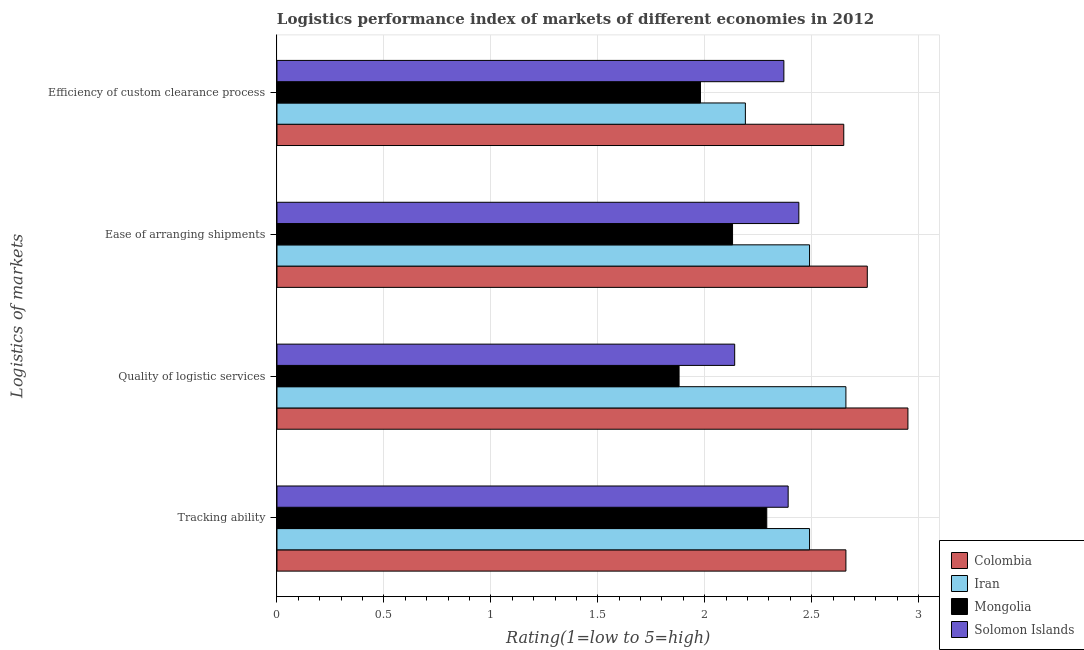How many groups of bars are there?
Your response must be concise. 4. Are the number of bars per tick equal to the number of legend labels?
Your answer should be very brief. Yes. What is the label of the 1st group of bars from the top?
Provide a succinct answer. Efficiency of custom clearance process. What is the lpi rating of ease of arranging shipments in Iran?
Provide a short and direct response. 2.49. Across all countries, what is the maximum lpi rating of quality of logistic services?
Provide a short and direct response. 2.95. Across all countries, what is the minimum lpi rating of ease of arranging shipments?
Your answer should be compact. 2.13. In which country was the lpi rating of quality of logistic services minimum?
Offer a very short reply. Mongolia. What is the total lpi rating of efficiency of custom clearance process in the graph?
Give a very brief answer. 9.19. What is the difference between the lpi rating of ease of arranging shipments in Iran and that in Solomon Islands?
Provide a short and direct response. 0.05. What is the difference between the lpi rating of efficiency of custom clearance process in Iran and the lpi rating of tracking ability in Mongolia?
Keep it short and to the point. -0.1. What is the average lpi rating of quality of logistic services per country?
Your answer should be very brief. 2.41. What is the difference between the lpi rating of ease of arranging shipments and lpi rating of tracking ability in Colombia?
Offer a terse response. 0.1. In how many countries, is the lpi rating of ease of arranging shipments greater than 0.7 ?
Give a very brief answer. 4. What is the ratio of the lpi rating of tracking ability in Iran to that in Colombia?
Your response must be concise. 0.94. Is the lpi rating of tracking ability in Mongolia less than that in Colombia?
Provide a short and direct response. Yes. Is the difference between the lpi rating of efficiency of custom clearance process in Colombia and Iran greater than the difference between the lpi rating of ease of arranging shipments in Colombia and Iran?
Give a very brief answer. Yes. What is the difference between the highest and the second highest lpi rating of quality of logistic services?
Offer a terse response. 0.29. What is the difference between the highest and the lowest lpi rating of tracking ability?
Your response must be concise. 0.37. In how many countries, is the lpi rating of efficiency of custom clearance process greater than the average lpi rating of efficiency of custom clearance process taken over all countries?
Offer a very short reply. 2. Is the sum of the lpi rating of quality of logistic services in Solomon Islands and Mongolia greater than the maximum lpi rating of efficiency of custom clearance process across all countries?
Offer a very short reply. Yes. What does the 2nd bar from the top in Efficiency of custom clearance process represents?
Your answer should be very brief. Mongolia. Are all the bars in the graph horizontal?
Your response must be concise. Yes. How many countries are there in the graph?
Keep it short and to the point. 4. Are the values on the major ticks of X-axis written in scientific E-notation?
Offer a very short reply. No. How many legend labels are there?
Provide a short and direct response. 4. How are the legend labels stacked?
Your response must be concise. Vertical. What is the title of the graph?
Provide a short and direct response. Logistics performance index of markets of different economies in 2012. Does "Poland" appear as one of the legend labels in the graph?
Keep it short and to the point. No. What is the label or title of the X-axis?
Offer a very short reply. Rating(1=low to 5=high). What is the label or title of the Y-axis?
Provide a short and direct response. Logistics of markets. What is the Rating(1=low to 5=high) of Colombia in Tracking ability?
Your response must be concise. 2.66. What is the Rating(1=low to 5=high) of Iran in Tracking ability?
Make the answer very short. 2.49. What is the Rating(1=low to 5=high) in Mongolia in Tracking ability?
Offer a very short reply. 2.29. What is the Rating(1=low to 5=high) in Solomon Islands in Tracking ability?
Your answer should be compact. 2.39. What is the Rating(1=low to 5=high) of Colombia in Quality of logistic services?
Make the answer very short. 2.95. What is the Rating(1=low to 5=high) in Iran in Quality of logistic services?
Keep it short and to the point. 2.66. What is the Rating(1=low to 5=high) of Mongolia in Quality of logistic services?
Ensure brevity in your answer.  1.88. What is the Rating(1=low to 5=high) of Solomon Islands in Quality of logistic services?
Offer a terse response. 2.14. What is the Rating(1=low to 5=high) in Colombia in Ease of arranging shipments?
Make the answer very short. 2.76. What is the Rating(1=low to 5=high) in Iran in Ease of arranging shipments?
Your answer should be compact. 2.49. What is the Rating(1=low to 5=high) in Mongolia in Ease of arranging shipments?
Provide a short and direct response. 2.13. What is the Rating(1=low to 5=high) in Solomon Islands in Ease of arranging shipments?
Your answer should be compact. 2.44. What is the Rating(1=low to 5=high) in Colombia in Efficiency of custom clearance process?
Your answer should be compact. 2.65. What is the Rating(1=low to 5=high) in Iran in Efficiency of custom clearance process?
Give a very brief answer. 2.19. What is the Rating(1=low to 5=high) of Mongolia in Efficiency of custom clearance process?
Offer a terse response. 1.98. What is the Rating(1=low to 5=high) of Solomon Islands in Efficiency of custom clearance process?
Your answer should be very brief. 2.37. Across all Logistics of markets, what is the maximum Rating(1=low to 5=high) of Colombia?
Ensure brevity in your answer.  2.95. Across all Logistics of markets, what is the maximum Rating(1=low to 5=high) in Iran?
Give a very brief answer. 2.66. Across all Logistics of markets, what is the maximum Rating(1=low to 5=high) of Mongolia?
Your response must be concise. 2.29. Across all Logistics of markets, what is the maximum Rating(1=low to 5=high) of Solomon Islands?
Offer a very short reply. 2.44. Across all Logistics of markets, what is the minimum Rating(1=low to 5=high) in Colombia?
Keep it short and to the point. 2.65. Across all Logistics of markets, what is the minimum Rating(1=low to 5=high) in Iran?
Your answer should be compact. 2.19. Across all Logistics of markets, what is the minimum Rating(1=low to 5=high) of Mongolia?
Give a very brief answer. 1.88. Across all Logistics of markets, what is the minimum Rating(1=low to 5=high) of Solomon Islands?
Give a very brief answer. 2.14. What is the total Rating(1=low to 5=high) of Colombia in the graph?
Make the answer very short. 11.02. What is the total Rating(1=low to 5=high) of Iran in the graph?
Your response must be concise. 9.83. What is the total Rating(1=low to 5=high) of Mongolia in the graph?
Make the answer very short. 8.28. What is the total Rating(1=low to 5=high) of Solomon Islands in the graph?
Provide a succinct answer. 9.34. What is the difference between the Rating(1=low to 5=high) of Colombia in Tracking ability and that in Quality of logistic services?
Offer a very short reply. -0.29. What is the difference between the Rating(1=low to 5=high) of Iran in Tracking ability and that in Quality of logistic services?
Offer a terse response. -0.17. What is the difference between the Rating(1=low to 5=high) of Mongolia in Tracking ability and that in Quality of logistic services?
Your answer should be compact. 0.41. What is the difference between the Rating(1=low to 5=high) in Iran in Tracking ability and that in Ease of arranging shipments?
Provide a succinct answer. 0. What is the difference between the Rating(1=low to 5=high) in Mongolia in Tracking ability and that in Ease of arranging shipments?
Your answer should be compact. 0.16. What is the difference between the Rating(1=low to 5=high) in Colombia in Tracking ability and that in Efficiency of custom clearance process?
Your answer should be very brief. 0.01. What is the difference between the Rating(1=low to 5=high) of Iran in Tracking ability and that in Efficiency of custom clearance process?
Provide a short and direct response. 0.3. What is the difference between the Rating(1=low to 5=high) of Mongolia in Tracking ability and that in Efficiency of custom clearance process?
Your answer should be compact. 0.31. What is the difference between the Rating(1=low to 5=high) of Colombia in Quality of logistic services and that in Ease of arranging shipments?
Provide a short and direct response. 0.19. What is the difference between the Rating(1=low to 5=high) in Iran in Quality of logistic services and that in Ease of arranging shipments?
Offer a terse response. 0.17. What is the difference between the Rating(1=low to 5=high) in Iran in Quality of logistic services and that in Efficiency of custom clearance process?
Provide a succinct answer. 0.47. What is the difference between the Rating(1=low to 5=high) in Mongolia in Quality of logistic services and that in Efficiency of custom clearance process?
Provide a succinct answer. -0.1. What is the difference between the Rating(1=low to 5=high) in Solomon Islands in Quality of logistic services and that in Efficiency of custom clearance process?
Your response must be concise. -0.23. What is the difference between the Rating(1=low to 5=high) in Colombia in Ease of arranging shipments and that in Efficiency of custom clearance process?
Provide a short and direct response. 0.11. What is the difference between the Rating(1=low to 5=high) of Iran in Ease of arranging shipments and that in Efficiency of custom clearance process?
Your response must be concise. 0.3. What is the difference between the Rating(1=low to 5=high) in Mongolia in Ease of arranging shipments and that in Efficiency of custom clearance process?
Provide a succinct answer. 0.15. What is the difference between the Rating(1=low to 5=high) of Solomon Islands in Ease of arranging shipments and that in Efficiency of custom clearance process?
Offer a very short reply. 0.07. What is the difference between the Rating(1=low to 5=high) of Colombia in Tracking ability and the Rating(1=low to 5=high) of Mongolia in Quality of logistic services?
Offer a very short reply. 0.78. What is the difference between the Rating(1=low to 5=high) of Colombia in Tracking ability and the Rating(1=low to 5=high) of Solomon Islands in Quality of logistic services?
Provide a succinct answer. 0.52. What is the difference between the Rating(1=low to 5=high) in Iran in Tracking ability and the Rating(1=low to 5=high) in Mongolia in Quality of logistic services?
Ensure brevity in your answer.  0.61. What is the difference between the Rating(1=low to 5=high) of Iran in Tracking ability and the Rating(1=low to 5=high) of Solomon Islands in Quality of logistic services?
Ensure brevity in your answer.  0.35. What is the difference between the Rating(1=low to 5=high) in Mongolia in Tracking ability and the Rating(1=low to 5=high) in Solomon Islands in Quality of logistic services?
Make the answer very short. 0.15. What is the difference between the Rating(1=low to 5=high) in Colombia in Tracking ability and the Rating(1=low to 5=high) in Iran in Ease of arranging shipments?
Make the answer very short. 0.17. What is the difference between the Rating(1=low to 5=high) in Colombia in Tracking ability and the Rating(1=low to 5=high) in Mongolia in Ease of arranging shipments?
Your response must be concise. 0.53. What is the difference between the Rating(1=low to 5=high) in Colombia in Tracking ability and the Rating(1=low to 5=high) in Solomon Islands in Ease of arranging shipments?
Your answer should be compact. 0.22. What is the difference between the Rating(1=low to 5=high) of Iran in Tracking ability and the Rating(1=low to 5=high) of Mongolia in Ease of arranging shipments?
Offer a terse response. 0.36. What is the difference between the Rating(1=low to 5=high) of Iran in Tracking ability and the Rating(1=low to 5=high) of Solomon Islands in Ease of arranging shipments?
Offer a terse response. 0.05. What is the difference between the Rating(1=low to 5=high) in Colombia in Tracking ability and the Rating(1=low to 5=high) in Iran in Efficiency of custom clearance process?
Keep it short and to the point. 0.47. What is the difference between the Rating(1=low to 5=high) of Colombia in Tracking ability and the Rating(1=low to 5=high) of Mongolia in Efficiency of custom clearance process?
Offer a very short reply. 0.68. What is the difference between the Rating(1=low to 5=high) in Colombia in Tracking ability and the Rating(1=low to 5=high) in Solomon Islands in Efficiency of custom clearance process?
Your response must be concise. 0.29. What is the difference between the Rating(1=low to 5=high) in Iran in Tracking ability and the Rating(1=low to 5=high) in Mongolia in Efficiency of custom clearance process?
Ensure brevity in your answer.  0.51. What is the difference between the Rating(1=low to 5=high) of Iran in Tracking ability and the Rating(1=low to 5=high) of Solomon Islands in Efficiency of custom clearance process?
Your response must be concise. 0.12. What is the difference between the Rating(1=low to 5=high) in Mongolia in Tracking ability and the Rating(1=low to 5=high) in Solomon Islands in Efficiency of custom clearance process?
Keep it short and to the point. -0.08. What is the difference between the Rating(1=low to 5=high) in Colombia in Quality of logistic services and the Rating(1=low to 5=high) in Iran in Ease of arranging shipments?
Offer a terse response. 0.46. What is the difference between the Rating(1=low to 5=high) of Colombia in Quality of logistic services and the Rating(1=low to 5=high) of Mongolia in Ease of arranging shipments?
Your answer should be compact. 0.82. What is the difference between the Rating(1=low to 5=high) of Colombia in Quality of logistic services and the Rating(1=low to 5=high) of Solomon Islands in Ease of arranging shipments?
Keep it short and to the point. 0.51. What is the difference between the Rating(1=low to 5=high) in Iran in Quality of logistic services and the Rating(1=low to 5=high) in Mongolia in Ease of arranging shipments?
Offer a terse response. 0.53. What is the difference between the Rating(1=low to 5=high) of Iran in Quality of logistic services and the Rating(1=low to 5=high) of Solomon Islands in Ease of arranging shipments?
Your answer should be compact. 0.22. What is the difference between the Rating(1=low to 5=high) in Mongolia in Quality of logistic services and the Rating(1=low to 5=high) in Solomon Islands in Ease of arranging shipments?
Provide a short and direct response. -0.56. What is the difference between the Rating(1=low to 5=high) of Colombia in Quality of logistic services and the Rating(1=low to 5=high) of Iran in Efficiency of custom clearance process?
Keep it short and to the point. 0.76. What is the difference between the Rating(1=low to 5=high) of Colombia in Quality of logistic services and the Rating(1=low to 5=high) of Solomon Islands in Efficiency of custom clearance process?
Your answer should be very brief. 0.58. What is the difference between the Rating(1=low to 5=high) of Iran in Quality of logistic services and the Rating(1=low to 5=high) of Mongolia in Efficiency of custom clearance process?
Your answer should be compact. 0.68. What is the difference between the Rating(1=low to 5=high) of Iran in Quality of logistic services and the Rating(1=low to 5=high) of Solomon Islands in Efficiency of custom clearance process?
Your answer should be compact. 0.29. What is the difference between the Rating(1=low to 5=high) of Mongolia in Quality of logistic services and the Rating(1=low to 5=high) of Solomon Islands in Efficiency of custom clearance process?
Make the answer very short. -0.49. What is the difference between the Rating(1=low to 5=high) of Colombia in Ease of arranging shipments and the Rating(1=low to 5=high) of Iran in Efficiency of custom clearance process?
Your response must be concise. 0.57. What is the difference between the Rating(1=low to 5=high) of Colombia in Ease of arranging shipments and the Rating(1=low to 5=high) of Mongolia in Efficiency of custom clearance process?
Make the answer very short. 0.78. What is the difference between the Rating(1=low to 5=high) in Colombia in Ease of arranging shipments and the Rating(1=low to 5=high) in Solomon Islands in Efficiency of custom clearance process?
Give a very brief answer. 0.39. What is the difference between the Rating(1=low to 5=high) in Iran in Ease of arranging shipments and the Rating(1=low to 5=high) in Mongolia in Efficiency of custom clearance process?
Keep it short and to the point. 0.51. What is the difference between the Rating(1=low to 5=high) in Iran in Ease of arranging shipments and the Rating(1=low to 5=high) in Solomon Islands in Efficiency of custom clearance process?
Keep it short and to the point. 0.12. What is the difference between the Rating(1=low to 5=high) in Mongolia in Ease of arranging shipments and the Rating(1=low to 5=high) in Solomon Islands in Efficiency of custom clearance process?
Provide a short and direct response. -0.24. What is the average Rating(1=low to 5=high) of Colombia per Logistics of markets?
Provide a succinct answer. 2.75. What is the average Rating(1=low to 5=high) in Iran per Logistics of markets?
Offer a very short reply. 2.46. What is the average Rating(1=low to 5=high) in Mongolia per Logistics of markets?
Keep it short and to the point. 2.07. What is the average Rating(1=low to 5=high) of Solomon Islands per Logistics of markets?
Ensure brevity in your answer.  2.33. What is the difference between the Rating(1=low to 5=high) of Colombia and Rating(1=low to 5=high) of Iran in Tracking ability?
Keep it short and to the point. 0.17. What is the difference between the Rating(1=low to 5=high) in Colombia and Rating(1=low to 5=high) in Mongolia in Tracking ability?
Provide a short and direct response. 0.37. What is the difference between the Rating(1=low to 5=high) in Colombia and Rating(1=low to 5=high) in Solomon Islands in Tracking ability?
Your response must be concise. 0.27. What is the difference between the Rating(1=low to 5=high) in Iran and Rating(1=low to 5=high) in Solomon Islands in Tracking ability?
Provide a short and direct response. 0.1. What is the difference between the Rating(1=low to 5=high) in Mongolia and Rating(1=low to 5=high) in Solomon Islands in Tracking ability?
Your response must be concise. -0.1. What is the difference between the Rating(1=low to 5=high) in Colombia and Rating(1=low to 5=high) in Iran in Quality of logistic services?
Offer a very short reply. 0.29. What is the difference between the Rating(1=low to 5=high) of Colombia and Rating(1=low to 5=high) of Mongolia in Quality of logistic services?
Your answer should be compact. 1.07. What is the difference between the Rating(1=low to 5=high) of Colombia and Rating(1=low to 5=high) of Solomon Islands in Quality of logistic services?
Your answer should be compact. 0.81. What is the difference between the Rating(1=low to 5=high) of Iran and Rating(1=low to 5=high) of Mongolia in Quality of logistic services?
Your answer should be compact. 0.78. What is the difference between the Rating(1=low to 5=high) in Iran and Rating(1=low to 5=high) in Solomon Islands in Quality of logistic services?
Offer a very short reply. 0.52. What is the difference between the Rating(1=low to 5=high) of Mongolia and Rating(1=low to 5=high) of Solomon Islands in Quality of logistic services?
Your answer should be compact. -0.26. What is the difference between the Rating(1=low to 5=high) of Colombia and Rating(1=low to 5=high) of Iran in Ease of arranging shipments?
Offer a terse response. 0.27. What is the difference between the Rating(1=low to 5=high) in Colombia and Rating(1=low to 5=high) in Mongolia in Ease of arranging shipments?
Make the answer very short. 0.63. What is the difference between the Rating(1=low to 5=high) in Colombia and Rating(1=low to 5=high) in Solomon Islands in Ease of arranging shipments?
Provide a succinct answer. 0.32. What is the difference between the Rating(1=low to 5=high) of Iran and Rating(1=low to 5=high) of Mongolia in Ease of arranging shipments?
Ensure brevity in your answer.  0.36. What is the difference between the Rating(1=low to 5=high) in Iran and Rating(1=low to 5=high) in Solomon Islands in Ease of arranging shipments?
Make the answer very short. 0.05. What is the difference between the Rating(1=low to 5=high) of Mongolia and Rating(1=low to 5=high) of Solomon Islands in Ease of arranging shipments?
Give a very brief answer. -0.31. What is the difference between the Rating(1=low to 5=high) in Colombia and Rating(1=low to 5=high) in Iran in Efficiency of custom clearance process?
Offer a terse response. 0.46. What is the difference between the Rating(1=low to 5=high) of Colombia and Rating(1=low to 5=high) of Mongolia in Efficiency of custom clearance process?
Provide a succinct answer. 0.67. What is the difference between the Rating(1=low to 5=high) in Colombia and Rating(1=low to 5=high) in Solomon Islands in Efficiency of custom clearance process?
Ensure brevity in your answer.  0.28. What is the difference between the Rating(1=low to 5=high) of Iran and Rating(1=low to 5=high) of Mongolia in Efficiency of custom clearance process?
Your response must be concise. 0.21. What is the difference between the Rating(1=low to 5=high) in Iran and Rating(1=low to 5=high) in Solomon Islands in Efficiency of custom clearance process?
Provide a short and direct response. -0.18. What is the difference between the Rating(1=low to 5=high) of Mongolia and Rating(1=low to 5=high) of Solomon Islands in Efficiency of custom clearance process?
Make the answer very short. -0.39. What is the ratio of the Rating(1=low to 5=high) in Colombia in Tracking ability to that in Quality of logistic services?
Offer a very short reply. 0.9. What is the ratio of the Rating(1=low to 5=high) of Iran in Tracking ability to that in Quality of logistic services?
Offer a very short reply. 0.94. What is the ratio of the Rating(1=low to 5=high) of Mongolia in Tracking ability to that in Quality of logistic services?
Provide a short and direct response. 1.22. What is the ratio of the Rating(1=low to 5=high) of Solomon Islands in Tracking ability to that in Quality of logistic services?
Give a very brief answer. 1.12. What is the ratio of the Rating(1=low to 5=high) in Colombia in Tracking ability to that in Ease of arranging shipments?
Give a very brief answer. 0.96. What is the ratio of the Rating(1=low to 5=high) in Iran in Tracking ability to that in Ease of arranging shipments?
Your answer should be compact. 1. What is the ratio of the Rating(1=low to 5=high) in Mongolia in Tracking ability to that in Ease of arranging shipments?
Keep it short and to the point. 1.08. What is the ratio of the Rating(1=low to 5=high) of Solomon Islands in Tracking ability to that in Ease of arranging shipments?
Your answer should be very brief. 0.98. What is the ratio of the Rating(1=low to 5=high) of Iran in Tracking ability to that in Efficiency of custom clearance process?
Your response must be concise. 1.14. What is the ratio of the Rating(1=low to 5=high) of Mongolia in Tracking ability to that in Efficiency of custom clearance process?
Your response must be concise. 1.16. What is the ratio of the Rating(1=low to 5=high) of Solomon Islands in Tracking ability to that in Efficiency of custom clearance process?
Your response must be concise. 1.01. What is the ratio of the Rating(1=low to 5=high) of Colombia in Quality of logistic services to that in Ease of arranging shipments?
Make the answer very short. 1.07. What is the ratio of the Rating(1=low to 5=high) in Iran in Quality of logistic services to that in Ease of arranging shipments?
Give a very brief answer. 1.07. What is the ratio of the Rating(1=low to 5=high) in Mongolia in Quality of logistic services to that in Ease of arranging shipments?
Offer a very short reply. 0.88. What is the ratio of the Rating(1=low to 5=high) in Solomon Islands in Quality of logistic services to that in Ease of arranging shipments?
Your answer should be compact. 0.88. What is the ratio of the Rating(1=low to 5=high) of Colombia in Quality of logistic services to that in Efficiency of custom clearance process?
Your answer should be very brief. 1.11. What is the ratio of the Rating(1=low to 5=high) of Iran in Quality of logistic services to that in Efficiency of custom clearance process?
Your answer should be very brief. 1.21. What is the ratio of the Rating(1=low to 5=high) of Mongolia in Quality of logistic services to that in Efficiency of custom clearance process?
Provide a short and direct response. 0.95. What is the ratio of the Rating(1=low to 5=high) in Solomon Islands in Quality of logistic services to that in Efficiency of custom clearance process?
Make the answer very short. 0.9. What is the ratio of the Rating(1=low to 5=high) in Colombia in Ease of arranging shipments to that in Efficiency of custom clearance process?
Provide a succinct answer. 1.04. What is the ratio of the Rating(1=low to 5=high) of Iran in Ease of arranging shipments to that in Efficiency of custom clearance process?
Your answer should be compact. 1.14. What is the ratio of the Rating(1=low to 5=high) of Mongolia in Ease of arranging shipments to that in Efficiency of custom clearance process?
Offer a very short reply. 1.08. What is the ratio of the Rating(1=low to 5=high) of Solomon Islands in Ease of arranging shipments to that in Efficiency of custom clearance process?
Your answer should be compact. 1.03. What is the difference between the highest and the second highest Rating(1=low to 5=high) of Colombia?
Offer a very short reply. 0.19. What is the difference between the highest and the second highest Rating(1=low to 5=high) of Iran?
Your response must be concise. 0.17. What is the difference between the highest and the second highest Rating(1=low to 5=high) of Mongolia?
Ensure brevity in your answer.  0.16. What is the difference between the highest and the second highest Rating(1=low to 5=high) in Solomon Islands?
Provide a short and direct response. 0.05. What is the difference between the highest and the lowest Rating(1=low to 5=high) in Iran?
Provide a succinct answer. 0.47. What is the difference between the highest and the lowest Rating(1=low to 5=high) of Mongolia?
Your answer should be very brief. 0.41. 